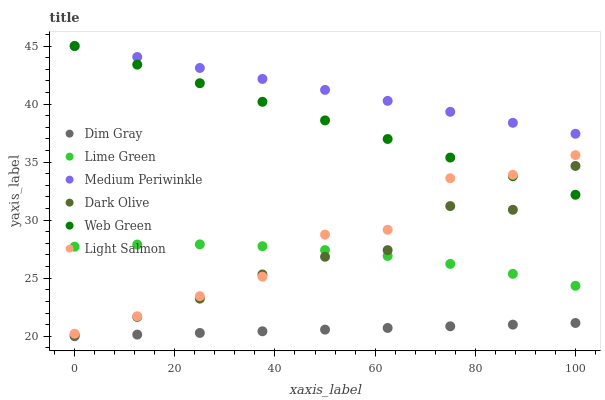Does Dim Gray have the minimum area under the curve?
Answer yes or no. Yes. Does Medium Periwinkle have the maximum area under the curve?
Answer yes or no. Yes. Does Dark Olive have the minimum area under the curve?
Answer yes or no. No. Does Dark Olive have the maximum area under the curve?
Answer yes or no. No. Is Medium Periwinkle the smoothest?
Answer yes or no. Yes. Is Light Salmon the roughest?
Answer yes or no. Yes. Is Dim Gray the smoothest?
Answer yes or no. No. Is Dim Gray the roughest?
Answer yes or no. No. Does Dim Gray have the lowest value?
Answer yes or no. Yes. Does Dark Olive have the lowest value?
Answer yes or no. No. Does Web Green have the highest value?
Answer yes or no. Yes. Does Dark Olive have the highest value?
Answer yes or no. No. Is Dim Gray less than Medium Periwinkle?
Answer yes or no. Yes. Is Medium Periwinkle greater than Dim Gray?
Answer yes or no. Yes. Does Web Green intersect Dark Olive?
Answer yes or no. Yes. Is Web Green less than Dark Olive?
Answer yes or no. No. Is Web Green greater than Dark Olive?
Answer yes or no. No. Does Dim Gray intersect Medium Periwinkle?
Answer yes or no. No. 